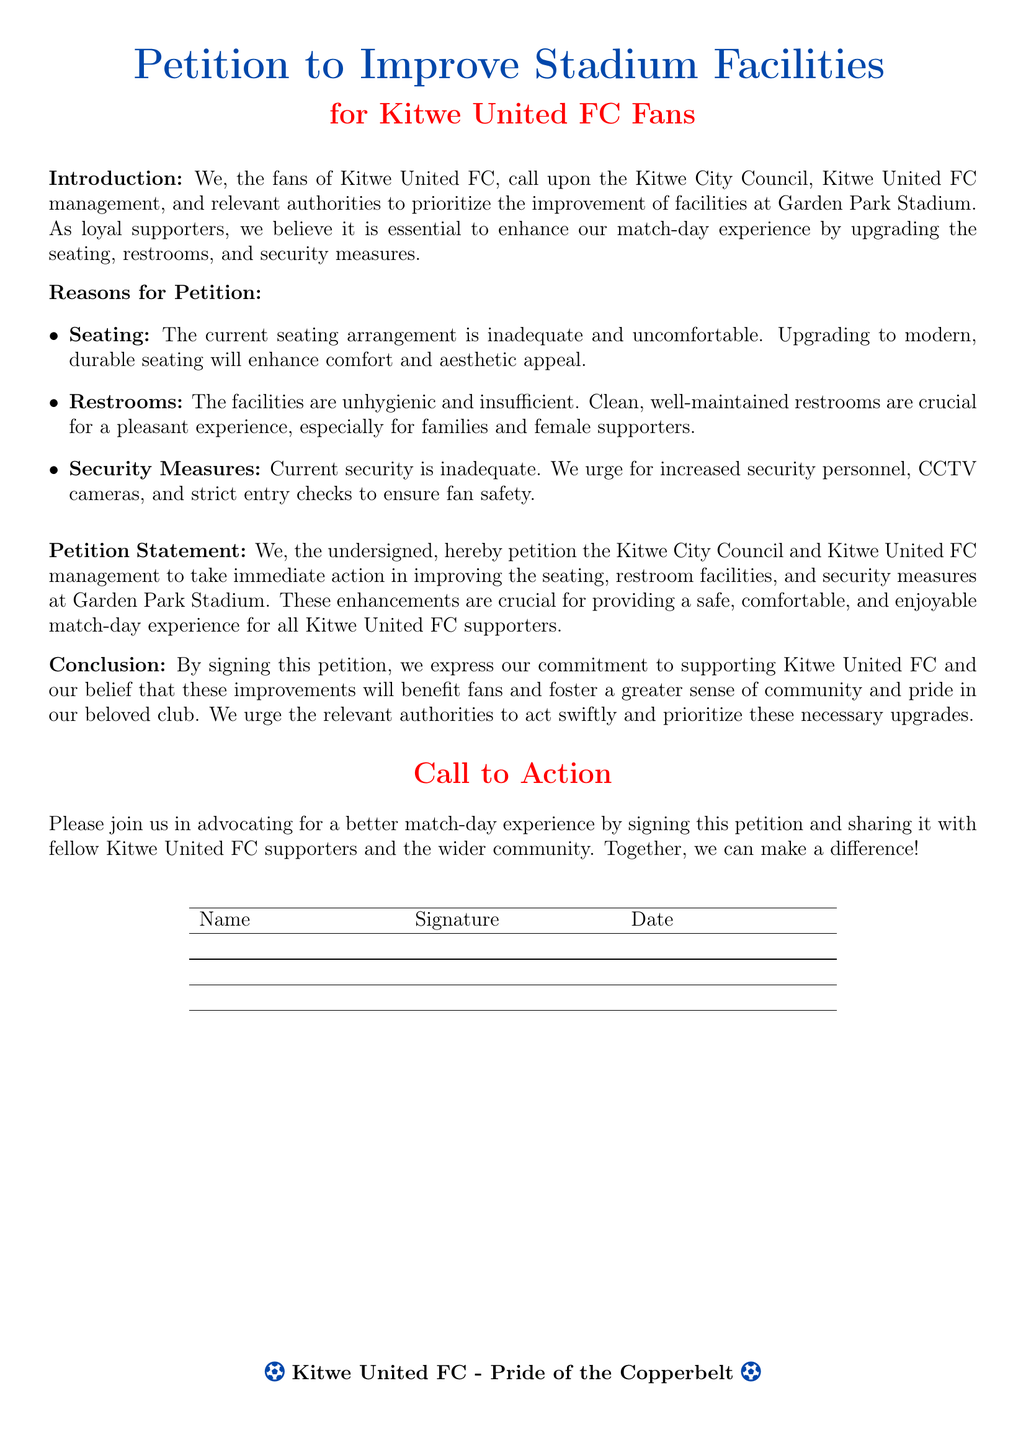what is the title of the petition? The title of the petition is prominently displayed at the top of the document, stating its purpose clearly.
Answer: Petition to Improve Stadium Facilities who is the petition aimed at? The petition is directed towards the Kitwe City Council and Kitwe United FC management, who are the relevant authorities responsible for the improvements.
Answer: Kitwe City Council, Kitwe United FC management what are the main facilities being requested for improvement? The petition outlines specific areas that need enhancement to improve the overall experience at the stadium.
Answer: Seating, restrooms, security measures how many reasons for the petition are listed? The document includes a list of specific reasons that justify the need for improvements in the facilities at the stadium.
Answer: Three what color is used for the title of the petition? The title is presented in a specific color that symbolizes the spirit of the petitioners, enhancing visibility and appeal.
Answer: Kitwe blue what is stated as crucial for families and female supporters? The document highlights the importance of a certain facility for specific groups of fans, underlining the need for proper amenities.
Answer: Clean, well-maintained restrooms what is the last section of the document called? The document concludes with a section that encourages readers to take action and support the cause presented in the petition.
Answer: Call to Action how are fans encouraged to engage with the petition? The petition encourages fans to participate actively by a certain action that helps to gather support for the improvements.
Answer: Signing the petition 